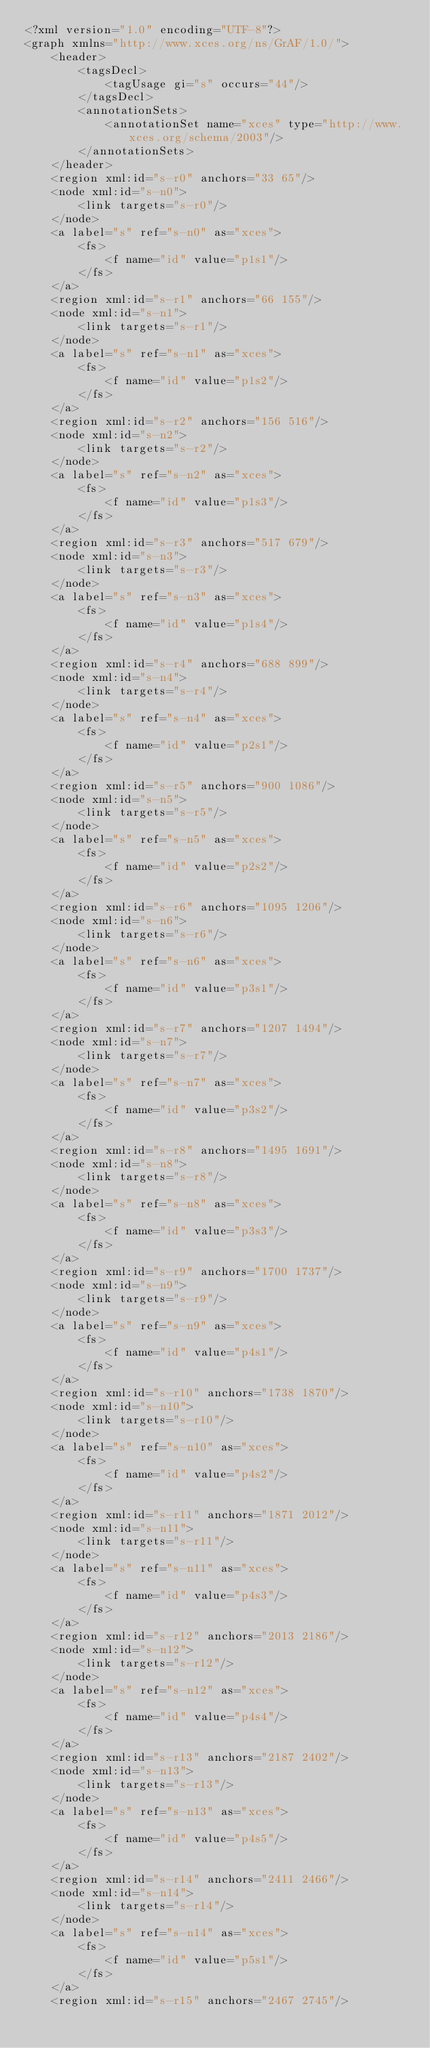<code> <loc_0><loc_0><loc_500><loc_500><_XML_><?xml version="1.0" encoding="UTF-8"?>
<graph xmlns="http://www.xces.org/ns/GrAF/1.0/">
    <header>
        <tagsDecl>
            <tagUsage gi="s" occurs="44"/>
        </tagsDecl>
        <annotationSets>
            <annotationSet name="xces" type="http://www.xces.org/schema/2003"/>
        </annotationSets>
    </header>
    <region xml:id="s-r0" anchors="33 65"/>
    <node xml:id="s-n0">
        <link targets="s-r0"/>
    </node>
    <a label="s" ref="s-n0" as="xces">
        <fs>
            <f name="id" value="p1s1"/>
        </fs>
    </a>
    <region xml:id="s-r1" anchors="66 155"/>
    <node xml:id="s-n1">
        <link targets="s-r1"/>
    </node>
    <a label="s" ref="s-n1" as="xces">
        <fs>
            <f name="id" value="p1s2"/>
        </fs>
    </a>
    <region xml:id="s-r2" anchors="156 516"/>
    <node xml:id="s-n2">
        <link targets="s-r2"/>
    </node>
    <a label="s" ref="s-n2" as="xces">
        <fs>
            <f name="id" value="p1s3"/>
        </fs>
    </a>
    <region xml:id="s-r3" anchors="517 679"/>
    <node xml:id="s-n3">
        <link targets="s-r3"/>
    </node>
    <a label="s" ref="s-n3" as="xces">
        <fs>
            <f name="id" value="p1s4"/>
        </fs>
    </a>
    <region xml:id="s-r4" anchors="688 899"/>
    <node xml:id="s-n4">
        <link targets="s-r4"/>
    </node>
    <a label="s" ref="s-n4" as="xces">
        <fs>
            <f name="id" value="p2s1"/>
        </fs>
    </a>
    <region xml:id="s-r5" anchors="900 1086"/>
    <node xml:id="s-n5">
        <link targets="s-r5"/>
    </node>
    <a label="s" ref="s-n5" as="xces">
        <fs>
            <f name="id" value="p2s2"/>
        </fs>
    </a>
    <region xml:id="s-r6" anchors="1095 1206"/>
    <node xml:id="s-n6">
        <link targets="s-r6"/>
    </node>
    <a label="s" ref="s-n6" as="xces">
        <fs>
            <f name="id" value="p3s1"/>
        </fs>
    </a>
    <region xml:id="s-r7" anchors="1207 1494"/>
    <node xml:id="s-n7">
        <link targets="s-r7"/>
    </node>
    <a label="s" ref="s-n7" as="xces">
        <fs>
            <f name="id" value="p3s2"/>
        </fs>
    </a>
    <region xml:id="s-r8" anchors="1495 1691"/>
    <node xml:id="s-n8">
        <link targets="s-r8"/>
    </node>
    <a label="s" ref="s-n8" as="xces">
        <fs>
            <f name="id" value="p3s3"/>
        </fs>
    </a>
    <region xml:id="s-r9" anchors="1700 1737"/>
    <node xml:id="s-n9">
        <link targets="s-r9"/>
    </node>
    <a label="s" ref="s-n9" as="xces">
        <fs>
            <f name="id" value="p4s1"/>
        </fs>
    </a>
    <region xml:id="s-r10" anchors="1738 1870"/>
    <node xml:id="s-n10">
        <link targets="s-r10"/>
    </node>
    <a label="s" ref="s-n10" as="xces">
        <fs>
            <f name="id" value="p4s2"/>
        </fs>
    </a>
    <region xml:id="s-r11" anchors="1871 2012"/>
    <node xml:id="s-n11">
        <link targets="s-r11"/>
    </node>
    <a label="s" ref="s-n11" as="xces">
        <fs>
            <f name="id" value="p4s3"/>
        </fs>
    </a>
    <region xml:id="s-r12" anchors="2013 2186"/>
    <node xml:id="s-n12">
        <link targets="s-r12"/>
    </node>
    <a label="s" ref="s-n12" as="xces">
        <fs>
            <f name="id" value="p4s4"/>
        </fs>
    </a>
    <region xml:id="s-r13" anchors="2187 2402"/>
    <node xml:id="s-n13">
        <link targets="s-r13"/>
    </node>
    <a label="s" ref="s-n13" as="xces">
        <fs>
            <f name="id" value="p4s5"/>
        </fs>
    </a>
    <region xml:id="s-r14" anchors="2411 2466"/>
    <node xml:id="s-n14">
        <link targets="s-r14"/>
    </node>
    <a label="s" ref="s-n14" as="xces">
        <fs>
            <f name="id" value="p5s1"/>
        </fs>
    </a>
    <region xml:id="s-r15" anchors="2467 2745"/></code> 